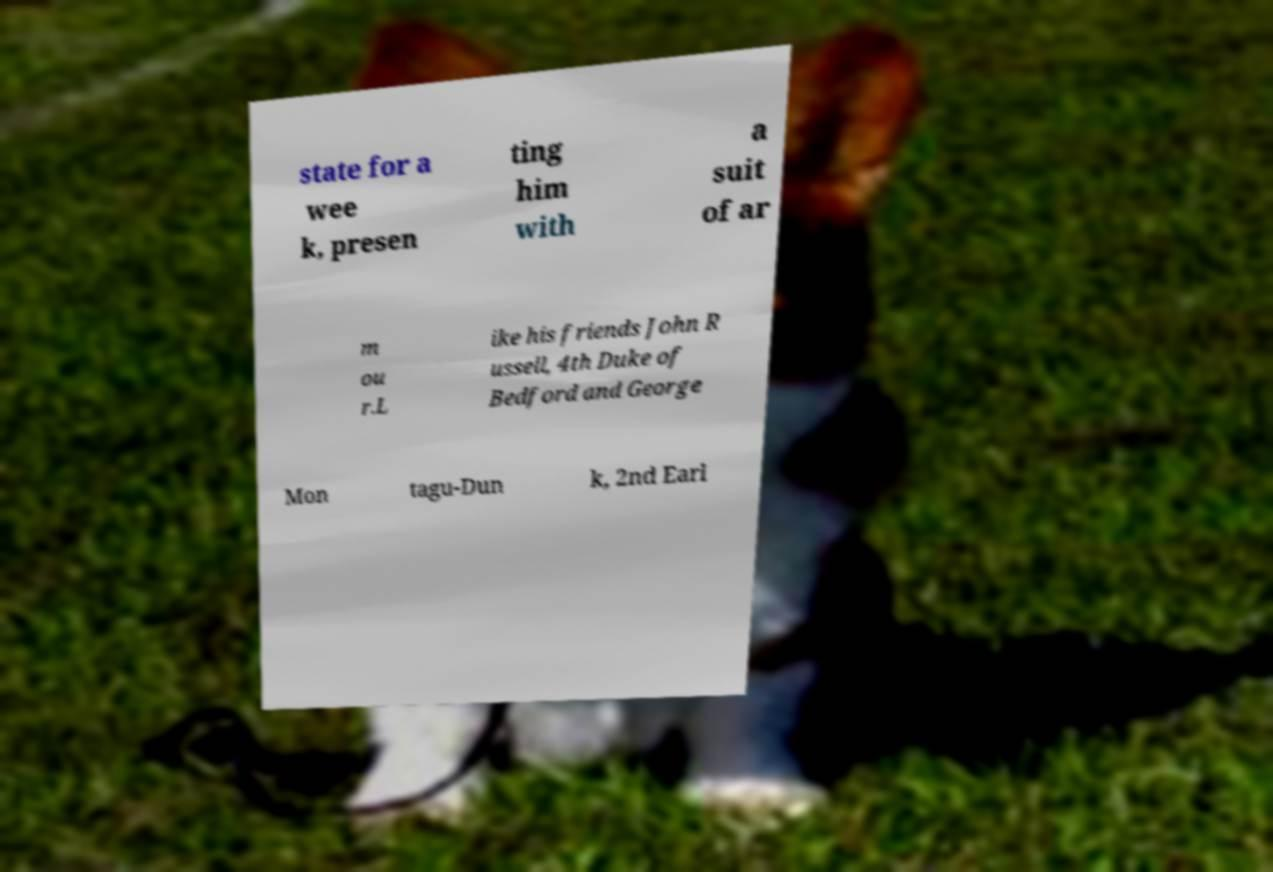Could you assist in decoding the text presented in this image and type it out clearly? state for a wee k, presen ting him with a suit of ar m ou r.L ike his friends John R ussell, 4th Duke of Bedford and George Mon tagu-Dun k, 2nd Earl 